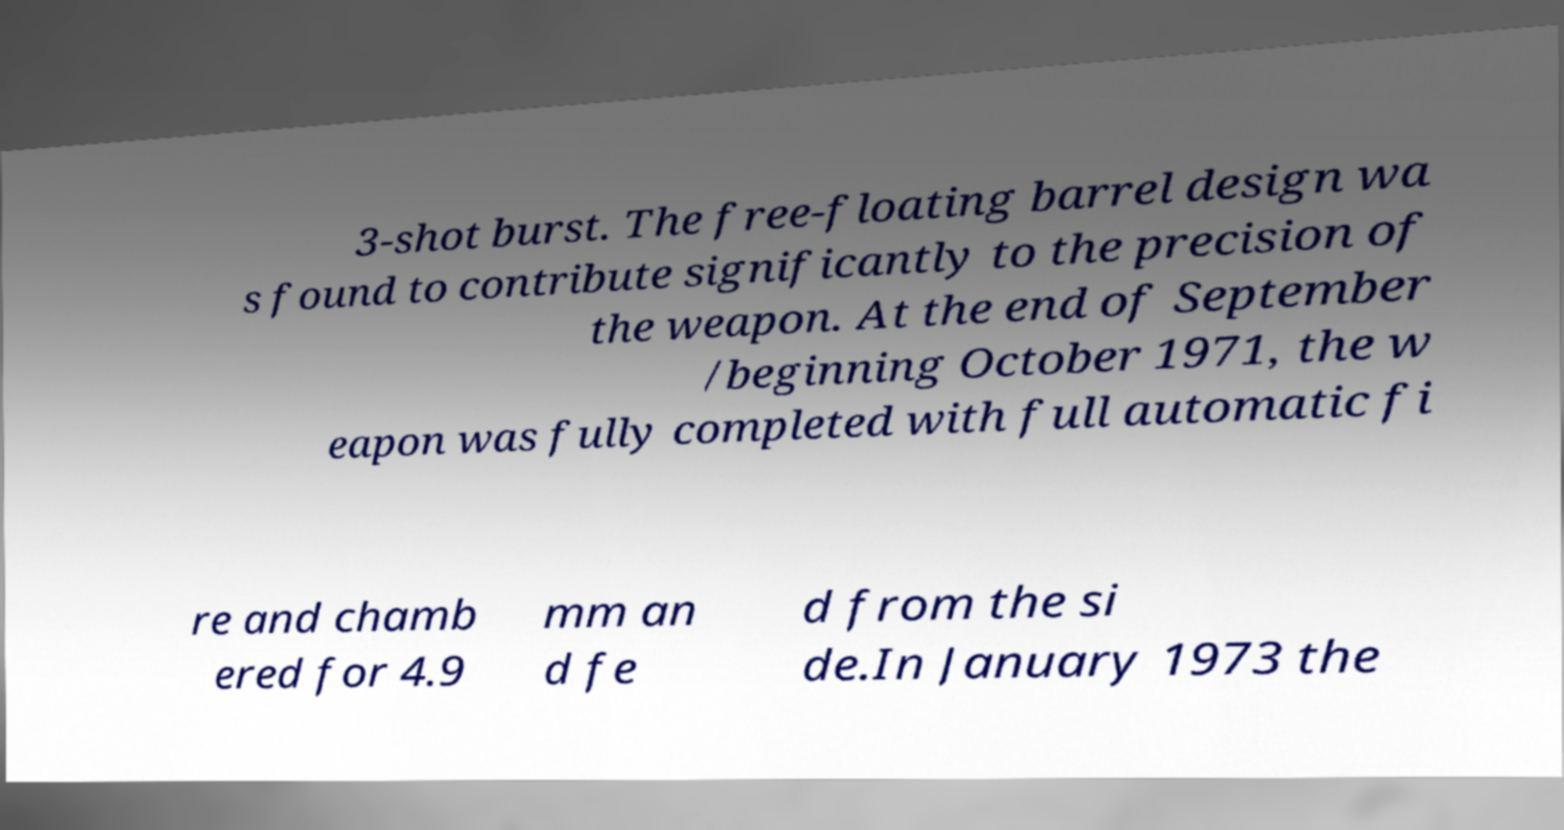Please read and relay the text visible in this image. What does it say? 3-shot burst. The free-floating barrel design wa s found to contribute significantly to the precision of the weapon. At the end of September /beginning October 1971, the w eapon was fully completed with full automatic fi re and chamb ered for 4.9 mm an d fe d from the si de.In January 1973 the 